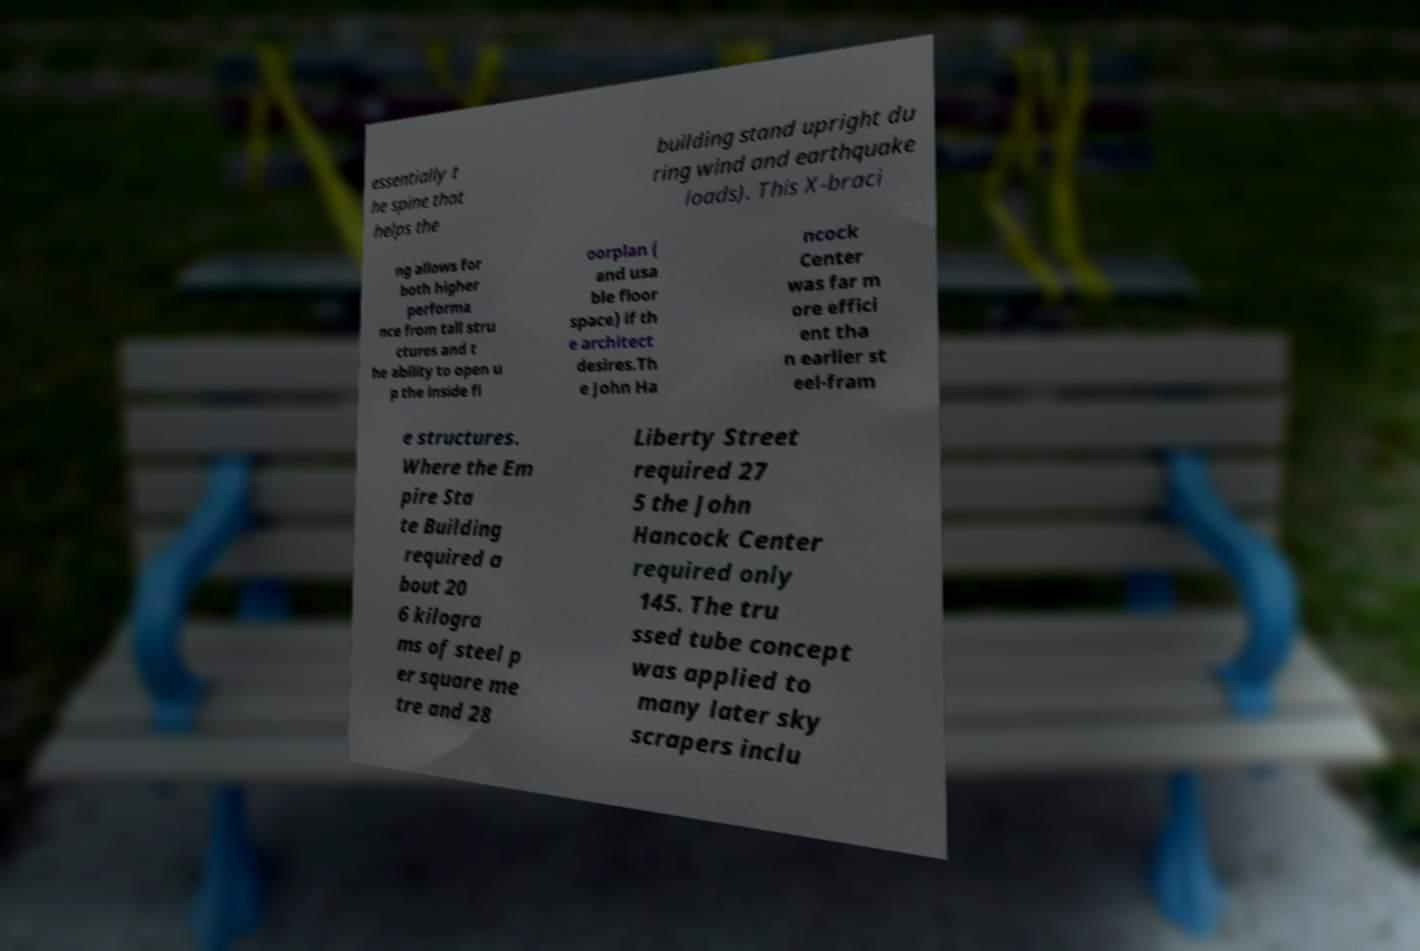Please identify and transcribe the text found in this image. essentially t he spine that helps the building stand upright du ring wind and earthquake loads). This X-braci ng allows for both higher performa nce from tall stru ctures and t he ability to open u p the inside fl oorplan ( and usa ble floor space) if th e architect desires.Th e John Ha ncock Center was far m ore effici ent tha n earlier st eel-fram e structures. Where the Em pire Sta te Building required a bout 20 6 kilogra ms of steel p er square me tre and 28 Liberty Street required 27 5 the John Hancock Center required only 145. The tru ssed tube concept was applied to many later sky scrapers inclu 